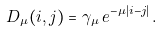Convert formula to latex. <formula><loc_0><loc_0><loc_500><loc_500>\ D _ { \mu } ( i , j ) = \gamma _ { \mu } \, e ^ { - \mu | i - j | } \, .</formula> 